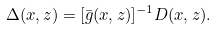<formula> <loc_0><loc_0><loc_500><loc_500>\Delta ( x , z ) = [ \bar { g } ( x , z ) ] ^ { - 1 } D ( x , z ) .</formula> 